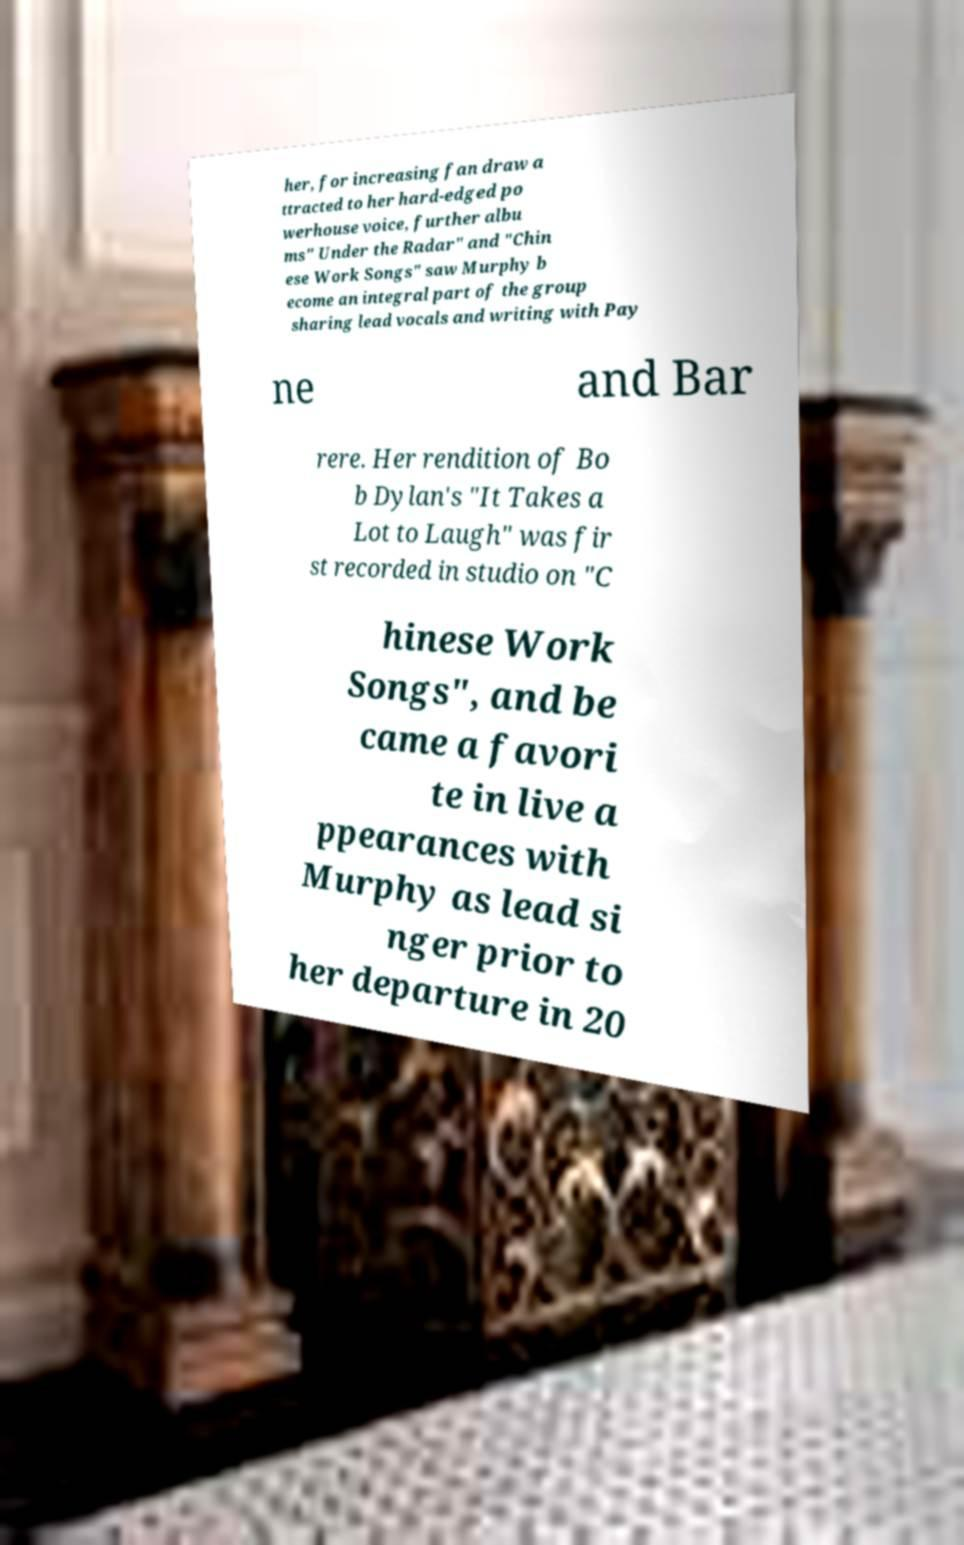Can you read and provide the text displayed in the image?This photo seems to have some interesting text. Can you extract and type it out for me? her, for increasing fan draw a ttracted to her hard-edged po werhouse voice, further albu ms" Under the Radar" and "Chin ese Work Songs" saw Murphy b ecome an integral part of the group sharing lead vocals and writing with Pay ne and Bar rere. Her rendition of Bo b Dylan's "It Takes a Lot to Laugh" was fir st recorded in studio on "C hinese Work Songs", and be came a favori te in live a ppearances with Murphy as lead si nger prior to her departure in 20 